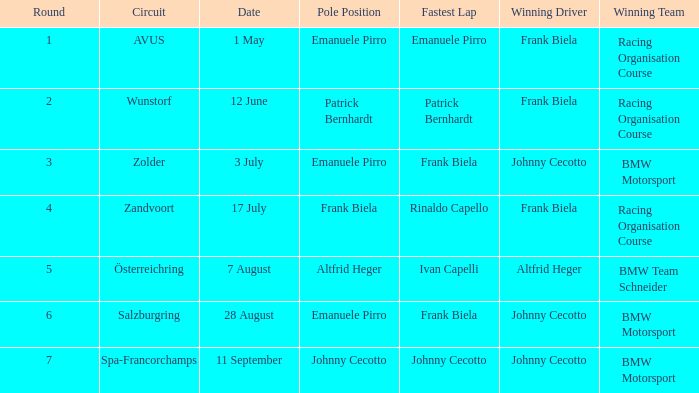On the zolder circuit, which team claimed the win? BMW Motorsport. 